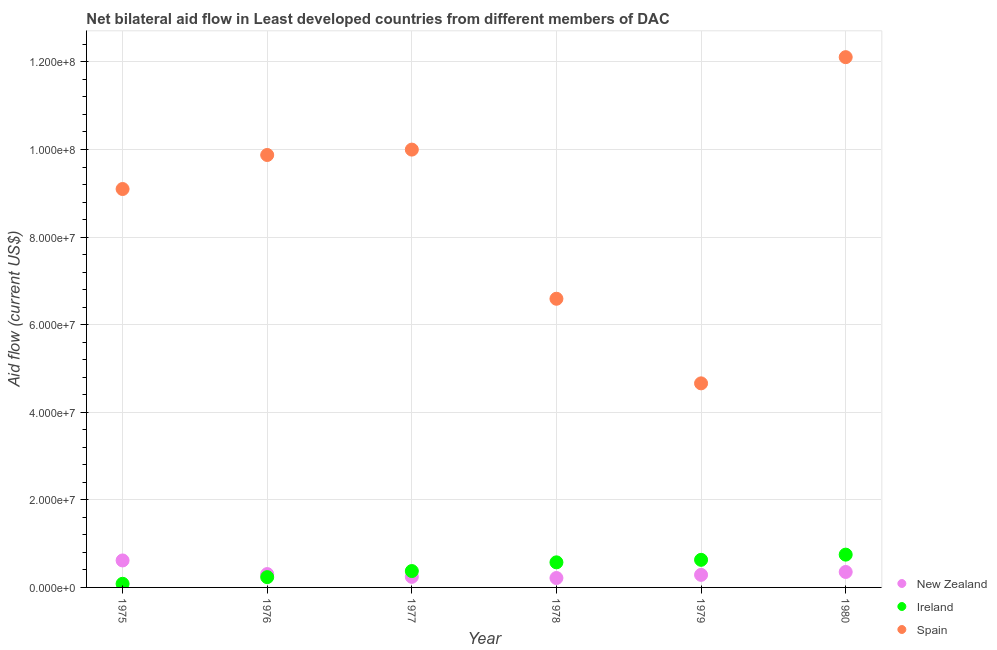What is the amount of aid provided by spain in 1977?
Offer a very short reply. 1.00e+08. Across all years, what is the maximum amount of aid provided by spain?
Your answer should be very brief. 1.21e+08. Across all years, what is the minimum amount of aid provided by new zealand?
Your answer should be very brief. 2.15e+06. In which year was the amount of aid provided by new zealand minimum?
Keep it short and to the point. 1978. What is the total amount of aid provided by new zealand in the graph?
Provide a succinct answer. 2.02e+07. What is the difference between the amount of aid provided by spain in 1977 and that in 1979?
Give a very brief answer. 5.34e+07. What is the difference between the amount of aid provided by spain in 1980 and the amount of aid provided by new zealand in 1977?
Provide a short and direct response. 1.19e+08. What is the average amount of aid provided by new zealand per year?
Give a very brief answer. 3.36e+06. In the year 1976, what is the difference between the amount of aid provided by new zealand and amount of aid provided by ireland?
Your answer should be very brief. 7.00e+05. What is the ratio of the amount of aid provided by spain in 1978 to that in 1979?
Provide a succinct answer. 1.41. What is the difference between the highest and the second highest amount of aid provided by ireland?
Ensure brevity in your answer.  1.19e+06. What is the difference between the highest and the lowest amount of aid provided by ireland?
Provide a succinct answer. 6.66e+06. In how many years, is the amount of aid provided by new zealand greater than the average amount of aid provided by new zealand taken over all years?
Offer a terse response. 2. Does the amount of aid provided by spain monotonically increase over the years?
Make the answer very short. No. Is the amount of aid provided by new zealand strictly greater than the amount of aid provided by spain over the years?
Offer a very short reply. No. Where does the legend appear in the graph?
Your answer should be very brief. Bottom right. How many legend labels are there?
Your answer should be compact. 3. How are the legend labels stacked?
Your answer should be compact. Vertical. What is the title of the graph?
Your answer should be compact. Net bilateral aid flow in Least developed countries from different members of DAC. What is the Aid flow (current US$) in New Zealand in 1975?
Offer a very short reply. 6.16e+06. What is the Aid flow (current US$) in Ireland in 1975?
Provide a succinct answer. 8.30e+05. What is the Aid flow (current US$) of Spain in 1975?
Your answer should be very brief. 9.10e+07. What is the Aid flow (current US$) of New Zealand in 1976?
Give a very brief answer. 3.05e+06. What is the Aid flow (current US$) of Ireland in 1976?
Offer a very short reply. 2.35e+06. What is the Aid flow (current US$) of Spain in 1976?
Provide a succinct answer. 9.88e+07. What is the Aid flow (current US$) in New Zealand in 1977?
Provide a short and direct response. 2.42e+06. What is the Aid flow (current US$) of Ireland in 1977?
Make the answer very short. 3.74e+06. What is the Aid flow (current US$) in Spain in 1977?
Ensure brevity in your answer.  1.00e+08. What is the Aid flow (current US$) of New Zealand in 1978?
Your answer should be compact. 2.15e+06. What is the Aid flow (current US$) in Ireland in 1978?
Ensure brevity in your answer.  5.73e+06. What is the Aid flow (current US$) of Spain in 1978?
Make the answer very short. 6.59e+07. What is the Aid flow (current US$) in New Zealand in 1979?
Ensure brevity in your answer.  2.87e+06. What is the Aid flow (current US$) in Ireland in 1979?
Provide a short and direct response. 6.30e+06. What is the Aid flow (current US$) of Spain in 1979?
Your answer should be very brief. 4.66e+07. What is the Aid flow (current US$) of New Zealand in 1980?
Your answer should be compact. 3.53e+06. What is the Aid flow (current US$) of Ireland in 1980?
Your answer should be very brief. 7.49e+06. What is the Aid flow (current US$) in Spain in 1980?
Your answer should be very brief. 1.21e+08. Across all years, what is the maximum Aid flow (current US$) of New Zealand?
Make the answer very short. 6.16e+06. Across all years, what is the maximum Aid flow (current US$) of Ireland?
Keep it short and to the point. 7.49e+06. Across all years, what is the maximum Aid flow (current US$) of Spain?
Your answer should be very brief. 1.21e+08. Across all years, what is the minimum Aid flow (current US$) in New Zealand?
Offer a very short reply. 2.15e+06. Across all years, what is the minimum Aid flow (current US$) of Ireland?
Offer a terse response. 8.30e+05. Across all years, what is the minimum Aid flow (current US$) in Spain?
Offer a terse response. 4.66e+07. What is the total Aid flow (current US$) in New Zealand in the graph?
Provide a short and direct response. 2.02e+07. What is the total Aid flow (current US$) in Ireland in the graph?
Give a very brief answer. 2.64e+07. What is the total Aid flow (current US$) in Spain in the graph?
Your response must be concise. 5.23e+08. What is the difference between the Aid flow (current US$) of New Zealand in 1975 and that in 1976?
Make the answer very short. 3.11e+06. What is the difference between the Aid flow (current US$) of Ireland in 1975 and that in 1976?
Your response must be concise. -1.52e+06. What is the difference between the Aid flow (current US$) of Spain in 1975 and that in 1976?
Make the answer very short. -7.77e+06. What is the difference between the Aid flow (current US$) of New Zealand in 1975 and that in 1977?
Give a very brief answer. 3.74e+06. What is the difference between the Aid flow (current US$) of Ireland in 1975 and that in 1977?
Offer a terse response. -2.91e+06. What is the difference between the Aid flow (current US$) of Spain in 1975 and that in 1977?
Give a very brief answer. -9.00e+06. What is the difference between the Aid flow (current US$) of New Zealand in 1975 and that in 1978?
Your answer should be very brief. 4.01e+06. What is the difference between the Aid flow (current US$) in Ireland in 1975 and that in 1978?
Give a very brief answer. -4.90e+06. What is the difference between the Aid flow (current US$) in Spain in 1975 and that in 1978?
Keep it short and to the point. 2.51e+07. What is the difference between the Aid flow (current US$) in New Zealand in 1975 and that in 1979?
Ensure brevity in your answer.  3.29e+06. What is the difference between the Aid flow (current US$) of Ireland in 1975 and that in 1979?
Provide a succinct answer. -5.47e+06. What is the difference between the Aid flow (current US$) in Spain in 1975 and that in 1979?
Offer a terse response. 4.44e+07. What is the difference between the Aid flow (current US$) in New Zealand in 1975 and that in 1980?
Make the answer very short. 2.63e+06. What is the difference between the Aid flow (current US$) of Ireland in 1975 and that in 1980?
Your response must be concise. -6.66e+06. What is the difference between the Aid flow (current US$) of Spain in 1975 and that in 1980?
Your answer should be compact. -3.01e+07. What is the difference between the Aid flow (current US$) in New Zealand in 1976 and that in 1977?
Give a very brief answer. 6.30e+05. What is the difference between the Aid flow (current US$) of Ireland in 1976 and that in 1977?
Your answer should be very brief. -1.39e+06. What is the difference between the Aid flow (current US$) of Spain in 1976 and that in 1977?
Provide a succinct answer. -1.23e+06. What is the difference between the Aid flow (current US$) of New Zealand in 1976 and that in 1978?
Offer a terse response. 9.00e+05. What is the difference between the Aid flow (current US$) of Ireland in 1976 and that in 1978?
Offer a terse response. -3.38e+06. What is the difference between the Aid flow (current US$) of Spain in 1976 and that in 1978?
Keep it short and to the point. 3.28e+07. What is the difference between the Aid flow (current US$) of New Zealand in 1976 and that in 1979?
Give a very brief answer. 1.80e+05. What is the difference between the Aid flow (current US$) in Ireland in 1976 and that in 1979?
Offer a terse response. -3.95e+06. What is the difference between the Aid flow (current US$) of Spain in 1976 and that in 1979?
Your answer should be very brief. 5.22e+07. What is the difference between the Aid flow (current US$) in New Zealand in 1976 and that in 1980?
Give a very brief answer. -4.80e+05. What is the difference between the Aid flow (current US$) of Ireland in 1976 and that in 1980?
Provide a short and direct response. -5.14e+06. What is the difference between the Aid flow (current US$) in Spain in 1976 and that in 1980?
Offer a very short reply. -2.23e+07. What is the difference between the Aid flow (current US$) in New Zealand in 1977 and that in 1978?
Give a very brief answer. 2.70e+05. What is the difference between the Aid flow (current US$) in Ireland in 1977 and that in 1978?
Give a very brief answer. -1.99e+06. What is the difference between the Aid flow (current US$) in Spain in 1977 and that in 1978?
Provide a short and direct response. 3.41e+07. What is the difference between the Aid flow (current US$) in New Zealand in 1977 and that in 1979?
Offer a very short reply. -4.50e+05. What is the difference between the Aid flow (current US$) of Ireland in 1977 and that in 1979?
Provide a succinct answer. -2.56e+06. What is the difference between the Aid flow (current US$) in Spain in 1977 and that in 1979?
Provide a short and direct response. 5.34e+07. What is the difference between the Aid flow (current US$) of New Zealand in 1977 and that in 1980?
Your answer should be very brief. -1.11e+06. What is the difference between the Aid flow (current US$) in Ireland in 1977 and that in 1980?
Provide a succinct answer. -3.75e+06. What is the difference between the Aid flow (current US$) in Spain in 1977 and that in 1980?
Give a very brief answer. -2.11e+07. What is the difference between the Aid flow (current US$) in New Zealand in 1978 and that in 1979?
Offer a very short reply. -7.20e+05. What is the difference between the Aid flow (current US$) of Ireland in 1978 and that in 1979?
Keep it short and to the point. -5.70e+05. What is the difference between the Aid flow (current US$) of Spain in 1978 and that in 1979?
Give a very brief answer. 1.93e+07. What is the difference between the Aid flow (current US$) of New Zealand in 1978 and that in 1980?
Your answer should be very brief. -1.38e+06. What is the difference between the Aid flow (current US$) in Ireland in 1978 and that in 1980?
Give a very brief answer. -1.76e+06. What is the difference between the Aid flow (current US$) of Spain in 1978 and that in 1980?
Your response must be concise. -5.52e+07. What is the difference between the Aid flow (current US$) of New Zealand in 1979 and that in 1980?
Give a very brief answer. -6.60e+05. What is the difference between the Aid flow (current US$) of Ireland in 1979 and that in 1980?
Your response must be concise. -1.19e+06. What is the difference between the Aid flow (current US$) in Spain in 1979 and that in 1980?
Your response must be concise. -7.45e+07. What is the difference between the Aid flow (current US$) of New Zealand in 1975 and the Aid flow (current US$) of Ireland in 1976?
Your response must be concise. 3.81e+06. What is the difference between the Aid flow (current US$) in New Zealand in 1975 and the Aid flow (current US$) in Spain in 1976?
Offer a very short reply. -9.26e+07. What is the difference between the Aid flow (current US$) in Ireland in 1975 and the Aid flow (current US$) in Spain in 1976?
Your response must be concise. -9.79e+07. What is the difference between the Aid flow (current US$) of New Zealand in 1975 and the Aid flow (current US$) of Ireland in 1977?
Give a very brief answer. 2.42e+06. What is the difference between the Aid flow (current US$) in New Zealand in 1975 and the Aid flow (current US$) in Spain in 1977?
Ensure brevity in your answer.  -9.38e+07. What is the difference between the Aid flow (current US$) in Ireland in 1975 and the Aid flow (current US$) in Spain in 1977?
Keep it short and to the point. -9.92e+07. What is the difference between the Aid flow (current US$) of New Zealand in 1975 and the Aid flow (current US$) of Spain in 1978?
Your answer should be very brief. -5.98e+07. What is the difference between the Aid flow (current US$) in Ireland in 1975 and the Aid flow (current US$) in Spain in 1978?
Your answer should be very brief. -6.51e+07. What is the difference between the Aid flow (current US$) of New Zealand in 1975 and the Aid flow (current US$) of Spain in 1979?
Offer a terse response. -4.04e+07. What is the difference between the Aid flow (current US$) in Ireland in 1975 and the Aid flow (current US$) in Spain in 1979?
Make the answer very short. -4.58e+07. What is the difference between the Aid flow (current US$) in New Zealand in 1975 and the Aid flow (current US$) in Ireland in 1980?
Ensure brevity in your answer.  -1.33e+06. What is the difference between the Aid flow (current US$) in New Zealand in 1975 and the Aid flow (current US$) in Spain in 1980?
Your response must be concise. -1.15e+08. What is the difference between the Aid flow (current US$) of Ireland in 1975 and the Aid flow (current US$) of Spain in 1980?
Provide a short and direct response. -1.20e+08. What is the difference between the Aid flow (current US$) in New Zealand in 1976 and the Aid flow (current US$) in Ireland in 1977?
Offer a very short reply. -6.90e+05. What is the difference between the Aid flow (current US$) of New Zealand in 1976 and the Aid flow (current US$) of Spain in 1977?
Your response must be concise. -9.69e+07. What is the difference between the Aid flow (current US$) in Ireland in 1976 and the Aid flow (current US$) in Spain in 1977?
Make the answer very short. -9.76e+07. What is the difference between the Aid flow (current US$) in New Zealand in 1976 and the Aid flow (current US$) in Ireland in 1978?
Your answer should be compact. -2.68e+06. What is the difference between the Aid flow (current US$) of New Zealand in 1976 and the Aid flow (current US$) of Spain in 1978?
Provide a succinct answer. -6.29e+07. What is the difference between the Aid flow (current US$) in Ireland in 1976 and the Aid flow (current US$) in Spain in 1978?
Make the answer very short. -6.36e+07. What is the difference between the Aid flow (current US$) in New Zealand in 1976 and the Aid flow (current US$) in Ireland in 1979?
Your response must be concise. -3.25e+06. What is the difference between the Aid flow (current US$) of New Zealand in 1976 and the Aid flow (current US$) of Spain in 1979?
Your answer should be very brief. -4.36e+07. What is the difference between the Aid flow (current US$) in Ireland in 1976 and the Aid flow (current US$) in Spain in 1979?
Provide a short and direct response. -4.42e+07. What is the difference between the Aid flow (current US$) in New Zealand in 1976 and the Aid flow (current US$) in Ireland in 1980?
Keep it short and to the point. -4.44e+06. What is the difference between the Aid flow (current US$) in New Zealand in 1976 and the Aid flow (current US$) in Spain in 1980?
Your answer should be very brief. -1.18e+08. What is the difference between the Aid flow (current US$) in Ireland in 1976 and the Aid flow (current US$) in Spain in 1980?
Your answer should be very brief. -1.19e+08. What is the difference between the Aid flow (current US$) in New Zealand in 1977 and the Aid flow (current US$) in Ireland in 1978?
Your response must be concise. -3.31e+06. What is the difference between the Aid flow (current US$) of New Zealand in 1977 and the Aid flow (current US$) of Spain in 1978?
Make the answer very short. -6.35e+07. What is the difference between the Aid flow (current US$) of Ireland in 1977 and the Aid flow (current US$) of Spain in 1978?
Your response must be concise. -6.22e+07. What is the difference between the Aid flow (current US$) of New Zealand in 1977 and the Aid flow (current US$) of Ireland in 1979?
Provide a succinct answer. -3.88e+06. What is the difference between the Aid flow (current US$) in New Zealand in 1977 and the Aid flow (current US$) in Spain in 1979?
Offer a very short reply. -4.42e+07. What is the difference between the Aid flow (current US$) of Ireland in 1977 and the Aid flow (current US$) of Spain in 1979?
Offer a very short reply. -4.29e+07. What is the difference between the Aid flow (current US$) in New Zealand in 1977 and the Aid flow (current US$) in Ireland in 1980?
Ensure brevity in your answer.  -5.07e+06. What is the difference between the Aid flow (current US$) of New Zealand in 1977 and the Aid flow (current US$) of Spain in 1980?
Your answer should be very brief. -1.19e+08. What is the difference between the Aid flow (current US$) of Ireland in 1977 and the Aid flow (current US$) of Spain in 1980?
Provide a succinct answer. -1.17e+08. What is the difference between the Aid flow (current US$) of New Zealand in 1978 and the Aid flow (current US$) of Ireland in 1979?
Your answer should be compact. -4.15e+06. What is the difference between the Aid flow (current US$) of New Zealand in 1978 and the Aid flow (current US$) of Spain in 1979?
Your answer should be compact. -4.44e+07. What is the difference between the Aid flow (current US$) of Ireland in 1978 and the Aid flow (current US$) of Spain in 1979?
Offer a terse response. -4.09e+07. What is the difference between the Aid flow (current US$) in New Zealand in 1978 and the Aid flow (current US$) in Ireland in 1980?
Your response must be concise. -5.34e+06. What is the difference between the Aid flow (current US$) of New Zealand in 1978 and the Aid flow (current US$) of Spain in 1980?
Keep it short and to the point. -1.19e+08. What is the difference between the Aid flow (current US$) in Ireland in 1978 and the Aid flow (current US$) in Spain in 1980?
Keep it short and to the point. -1.15e+08. What is the difference between the Aid flow (current US$) of New Zealand in 1979 and the Aid flow (current US$) of Ireland in 1980?
Ensure brevity in your answer.  -4.62e+06. What is the difference between the Aid flow (current US$) in New Zealand in 1979 and the Aid flow (current US$) in Spain in 1980?
Keep it short and to the point. -1.18e+08. What is the difference between the Aid flow (current US$) of Ireland in 1979 and the Aid flow (current US$) of Spain in 1980?
Ensure brevity in your answer.  -1.15e+08. What is the average Aid flow (current US$) in New Zealand per year?
Your answer should be compact. 3.36e+06. What is the average Aid flow (current US$) of Ireland per year?
Your response must be concise. 4.41e+06. What is the average Aid flow (current US$) of Spain per year?
Offer a terse response. 8.72e+07. In the year 1975, what is the difference between the Aid flow (current US$) of New Zealand and Aid flow (current US$) of Ireland?
Keep it short and to the point. 5.33e+06. In the year 1975, what is the difference between the Aid flow (current US$) of New Zealand and Aid flow (current US$) of Spain?
Provide a short and direct response. -8.48e+07. In the year 1975, what is the difference between the Aid flow (current US$) in Ireland and Aid flow (current US$) in Spain?
Give a very brief answer. -9.02e+07. In the year 1976, what is the difference between the Aid flow (current US$) in New Zealand and Aid flow (current US$) in Spain?
Keep it short and to the point. -9.57e+07. In the year 1976, what is the difference between the Aid flow (current US$) in Ireland and Aid flow (current US$) in Spain?
Keep it short and to the point. -9.64e+07. In the year 1977, what is the difference between the Aid flow (current US$) of New Zealand and Aid flow (current US$) of Ireland?
Give a very brief answer. -1.32e+06. In the year 1977, what is the difference between the Aid flow (current US$) in New Zealand and Aid flow (current US$) in Spain?
Make the answer very short. -9.76e+07. In the year 1977, what is the difference between the Aid flow (current US$) in Ireland and Aid flow (current US$) in Spain?
Your answer should be compact. -9.62e+07. In the year 1978, what is the difference between the Aid flow (current US$) in New Zealand and Aid flow (current US$) in Ireland?
Provide a succinct answer. -3.58e+06. In the year 1978, what is the difference between the Aid flow (current US$) in New Zealand and Aid flow (current US$) in Spain?
Offer a terse response. -6.38e+07. In the year 1978, what is the difference between the Aid flow (current US$) in Ireland and Aid flow (current US$) in Spain?
Provide a succinct answer. -6.02e+07. In the year 1979, what is the difference between the Aid flow (current US$) in New Zealand and Aid flow (current US$) in Ireland?
Your answer should be compact. -3.43e+06. In the year 1979, what is the difference between the Aid flow (current US$) in New Zealand and Aid flow (current US$) in Spain?
Offer a very short reply. -4.37e+07. In the year 1979, what is the difference between the Aid flow (current US$) of Ireland and Aid flow (current US$) of Spain?
Make the answer very short. -4.03e+07. In the year 1980, what is the difference between the Aid flow (current US$) in New Zealand and Aid flow (current US$) in Ireland?
Give a very brief answer. -3.96e+06. In the year 1980, what is the difference between the Aid flow (current US$) of New Zealand and Aid flow (current US$) of Spain?
Make the answer very short. -1.18e+08. In the year 1980, what is the difference between the Aid flow (current US$) in Ireland and Aid flow (current US$) in Spain?
Your answer should be very brief. -1.14e+08. What is the ratio of the Aid flow (current US$) in New Zealand in 1975 to that in 1976?
Your answer should be compact. 2.02. What is the ratio of the Aid flow (current US$) of Ireland in 1975 to that in 1976?
Keep it short and to the point. 0.35. What is the ratio of the Aid flow (current US$) in Spain in 1975 to that in 1976?
Make the answer very short. 0.92. What is the ratio of the Aid flow (current US$) of New Zealand in 1975 to that in 1977?
Offer a terse response. 2.55. What is the ratio of the Aid flow (current US$) of Ireland in 1975 to that in 1977?
Your answer should be compact. 0.22. What is the ratio of the Aid flow (current US$) of Spain in 1975 to that in 1977?
Ensure brevity in your answer.  0.91. What is the ratio of the Aid flow (current US$) of New Zealand in 1975 to that in 1978?
Offer a terse response. 2.87. What is the ratio of the Aid flow (current US$) of Ireland in 1975 to that in 1978?
Offer a terse response. 0.14. What is the ratio of the Aid flow (current US$) in Spain in 1975 to that in 1978?
Your answer should be compact. 1.38. What is the ratio of the Aid flow (current US$) in New Zealand in 1975 to that in 1979?
Provide a short and direct response. 2.15. What is the ratio of the Aid flow (current US$) in Ireland in 1975 to that in 1979?
Provide a succinct answer. 0.13. What is the ratio of the Aid flow (current US$) of Spain in 1975 to that in 1979?
Offer a very short reply. 1.95. What is the ratio of the Aid flow (current US$) in New Zealand in 1975 to that in 1980?
Your response must be concise. 1.75. What is the ratio of the Aid flow (current US$) in Ireland in 1975 to that in 1980?
Your answer should be very brief. 0.11. What is the ratio of the Aid flow (current US$) of Spain in 1975 to that in 1980?
Your answer should be very brief. 0.75. What is the ratio of the Aid flow (current US$) of New Zealand in 1976 to that in 1977?
Your response must be concise. 1.26. What is the ratio of the Aid flow (current US$) of Ireland in 1976 to that in 1977?
Offer a very short reply. 0.63. What is the ratio of the Aid flow (current US$) of New Zealand in 1976 to that in 1978?
Your answer should be very brief. 1.42. What is the ratio of the Aid flow (current US$) in Ireland in 1976 to that in 1978?
Give a very brief answer. 0.41. What is the ratio of the Aid flow (current US$) in Spain in 1976 to that in 1978?
Make the answer very short. 1.5. What is the ratio of the Aid flow (current US$) in New Zealand in 1976 to that in 1979?
Your answer should be very brief. 1.06. What is the ratio of the Aid flow (current US$) in Ireland in 1976 to that in 1979?
Make the answer very short. 0.37. What is the ratio of the Aid flow (current US$) in Spain in 1976 to that in 1979?
Your answer should be compact. 2.12. What is the ratio of the Aid flow (current US$) in New Zealand in 1976 to that in 1980?
Provide a succinct answer. 0.86. What is the ratio of the Aid flow (current US$) of Ireland in 1976 to that in 1980?
Make the answer very short. 0.31. What is the ratio of the Aid flow (current US$) of Spain in 1976 to that in 1980?
Keep it short and to the point. 0.82. What is the ratio of the Aid flow (current US$) of New Zealand in 1977 to that in 1978?
Ensure brevity in your answer.  1.13. What is the ratio of the Aid flow (current US$) of Ireland in 1977 to that in 1978?
Provide a short and direct response. 0.65. What is the ratio of the Aid flow (current US$) in Spain in 1977 to that in 1978?
Give a very brief answer. 1.52. What is the ratio of the Aid flow (current US$) of New Zealand in 1977 to that in 1979?
Offer a very short reply. 0.84. What is the ratio of the Aid flow (current US$) in Ireland in 1977 to that in 1979?
Provide a short and direct response. 0.59. What is the ratio of the Aid flow (current US$) in Spain in 1977 to that in 1979?
Keep it short and to the point. 2.15. What is the ratio of the Aid flow (current US$) of New Zealand in 1977 to that in 1980?
Your answer should be very brief. 0.69. What is the ratio of the Aid flow (current US$) in Ireland in 1977 to that in 1980?
Your answer should be compact. 0.5. What is the ratio of the Aid flow (current US$) in Spain in 1977 to that in 1980?
Provide a short and direct response. 0.83. What is the ratio of the Aid flow (current US$) in New Zealand in 1978 to that in 1979?
Your response must be concise. 0.75. What is the ratio of the Aid flow (current US$) in Ireland in 1978 to that in 1979?
Your answer should be compact. 0.91. What is the ratio of the Aid flow (current US$) of Spain in 1978 to that in 1979?
Offer a very short reply. 1.41. What is the ratio of the Aid flow (current US$) of New Zealand in 1978 to that in 1980?
Offer a terse response. 0.61. What is the ratio of the Aid flow (current US$) of Ireland in 1978 to that in 1980?
Ensure brevity in your answer.  0.77. What is the ratio of the Aid flow (current US$) in Spain in 1978 to that in 1980?
Offer a very short reply. 0.54. What is the ratio of the Aid flow (current US$) of New Zealand in 1979 to that in 1980?
Offer a very short reply. 0.81. What is the ratio of the Aid flow (current US$) of Ireland in 1979 to that in 1980?
Ensure brevity in your answer.  0.84. What is the ratio of the Aid flow (current US$) of Spain in 1979 to that in 1980?
Give a very brief answer. 0.38. What is the difference between the highest and the second highest Aid flow (current US$) in New Zealand?
Your response must be concise. 2.63e+06. What is the difference between the highest and the second highest Aid flow (current US$) of Ireland?
Keep it short and to the point. 1.19e+06. What is the difference between the highest and the second highest Aid flow (current US$) in Spain?
Offer a terse response. 2.11e+07. What is the difference between the highest and the lowest Aid flow (current US$) of New Zealand?
Provide a short and direct response. 4.01e+06. What is the difference between the highest and the lowest Aid flow (current US$) of Ireland?
Offer a very short reply. 6.66e+06. What is the difference between the highest and the lowest Aid flow (current US$) of Spain?
Your answer should be compact. 7.45e+07. 